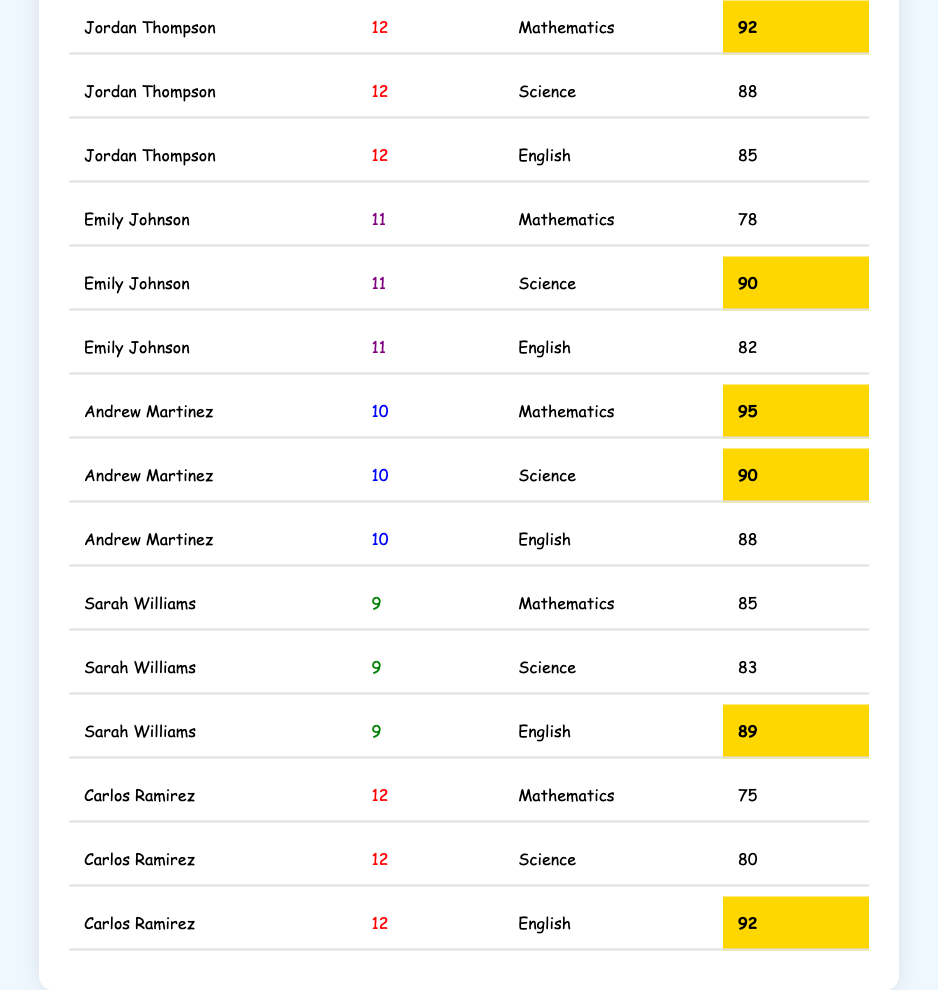What is the highest score in Mathematics? The highest score in Mathematics is found by looking at the scores in the Mathematics column. The scores are 92 (Jordan Thompson), 78 (Emily Johnson), 95 (Andrew Martinez), 85 (Sarah Williams), and 75 (Carlos Ramirez). Comparing these values, 95 is the highest.
Answer: 95 Who scored a perfect Mathematics score? There is no score provided for perfect Mathematics (100), so I will check each student's Mathematics score. None of the scores reach 100 based on the data provided.
Answer: No What is the average score of Emily Johnson across all subjects? To find the average, sum her scores in all subjects (78 + 90 + 82) = 250. Then, divide by the number of subjects (3). Therefore, the average score is 250 / 3 = approximately 83.33.
Answer: 83.33 Which student has the highest Science score? Checking the Science scores: Jordan Thompson (88), Emily Johnson (90), Andrew Martinez (90), Sarah Williams (83), and Carlos Ramirez (80). Both Andrew and Emily have the highest score of 90.
Answer: Andrew Martinez and Emily Johnson What is the total score of Jordan Thompson in all subjects? The total score can be determined by adding up all of Jordan Thompson's scores: 92 (Mathematics) + 88 (Science) + 85 (English) = 265.
Answer: 265 Which student has the highest score in English? The English scores are: 85 (Jordan Thompson), 82 (Emily Johnson), 88 (Andrew Martinez), 89 (Sarah Williams), and 92 (Carlos Ramirez). The highest score is 92 by Carlos Ramirez.
Answer: Carlos Ramirez Was the average score of Andrew Martinez higher than Jordan Thompson's average score? Calculate Andrew's average: (95 + 90 + 88) = 273, then 273 / 3 = 91. For Jordan: (92 + 88 + 85) = 265, then 265 / 3 = approximately 88.33. Since 91 is greater than 88.33, Andrew has the higher average.
Answer: Yes What percentage of Jordan Thompson’s scores are highlighted? Jordan has three subjects scored, and only one score is highlighted (92 in Mathematics). To find the percentage, (1/3)*100 = 33.33%.
Answer: 33.33% How many students scored above 90 in any subject? Count the scores above 90: 92 (Jordan Thompson), 90 (Emily Johnson), 95 (Andrew Martinez), and 92 (Carlos Ramirez). That's four scores above 90.
Answer: 4 What is the minimum score for each subject among the students listed? The minimum scores are: Mathematics: 75 (Carlos Ramirez), Science: 80 (Carlos Ramirez), English: 82 (Emily Johnson). The lowest for each subject can be clearly identified in the table.
Answer: Mathematics: 75, Science: 80, English: 82 